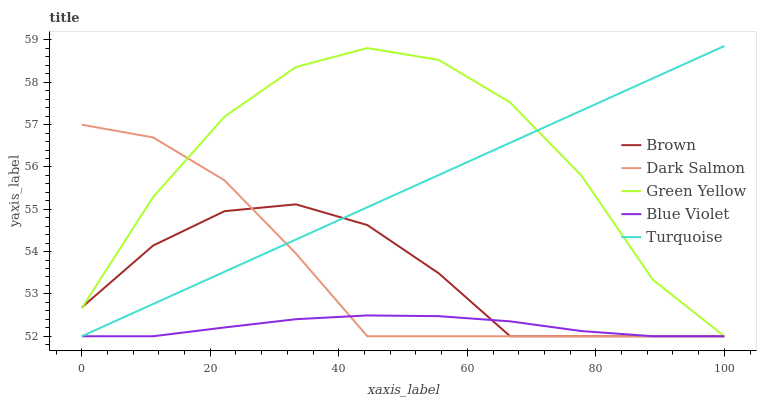Does Blue Violet have the minimum area under the curve?
Answer yes or no. Yes. Does Green Yellow have the maximum area under the curve?
Answer yes or no. Yes. Does Turquoise have the minimum area under the curve?
Answer yes or no. No. Does Turquoise have the maximum area under the curve?
Answer yes or no. No. Is Turquoise the smoothest?
Answer yes or no. Yes. Is Green Yellow the roughest?
Answer yes or no. Yes. Is Green Yellow the smoothest?
Answer yes or no. No. Is Turquoise the roughest?
Answer yes or no. No. Does Brown have the lowest value?
Answer yes or no. Yes. Does Turquoise have the highest value?
Answer yes or no. Yes. Does Green Yellow have the highest value?
Answer yes or no. No. Does Green Yellow intersect Blue Violet?
Answer yes or no. Yes. Is Green Yellow less than Blue Violet?
Answer yes or no. No. Is Green Yellow greater than Blue Violet?
Answer yes or no. No. 